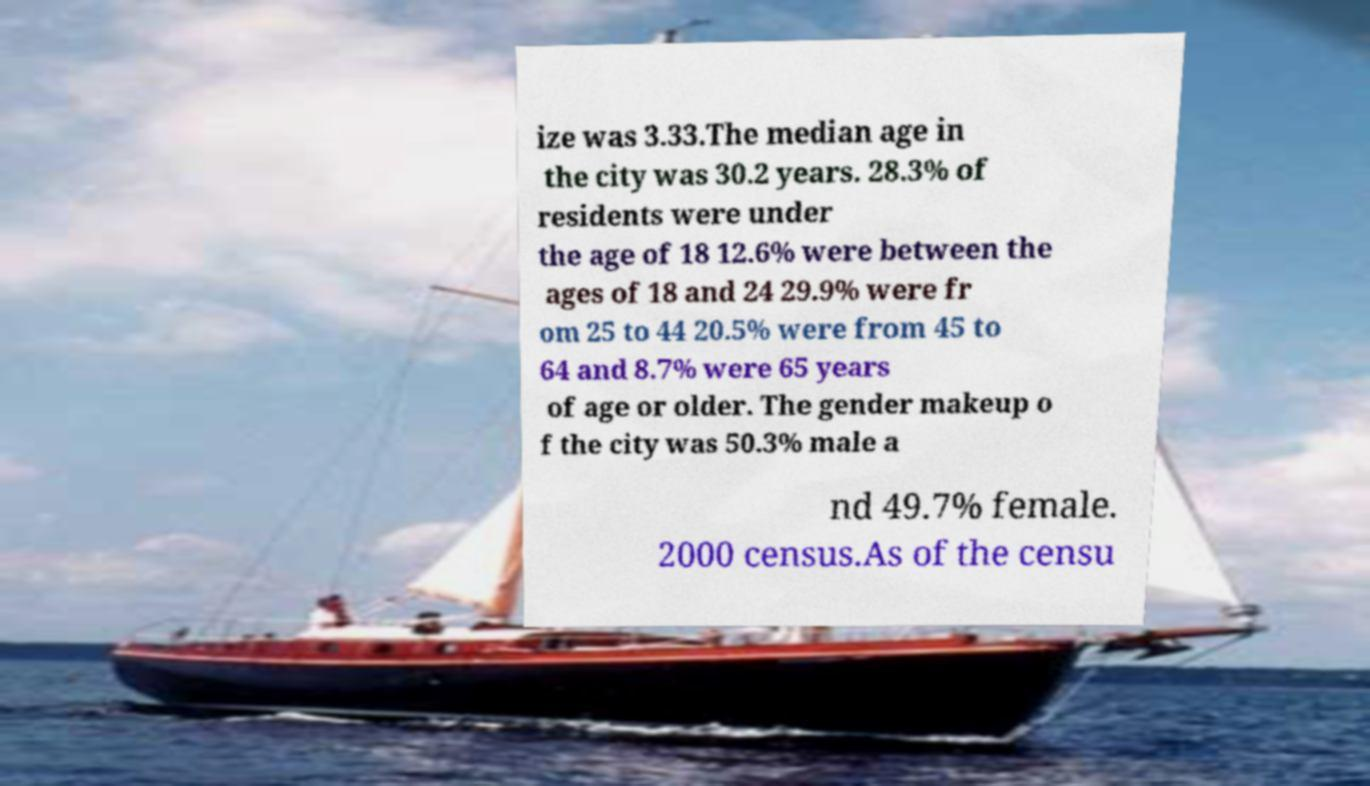Can you read and provide the text displayed in the image?This photo seems to have some interesting text. Can you extract and type it out for me? ize was 3.33.The median age in the city was 30.2 years. 28.3% of residents were under the age of 18 12.6% were between the ages of 18 and 24 29.9% were fr om 25 to 44 20.5% were from 45 to 64 and 8.7% were 65 years of age or older. The gender makeup o f the city was 50.3% male a nd 49.7% female. 2000 census.As of the censu 